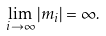Convert formula to latex. <formula><loc_0><loc_0><loc_500><loc_500>\lim _ { i \to \infty } | m _ { i } | = \infty .</formula> 